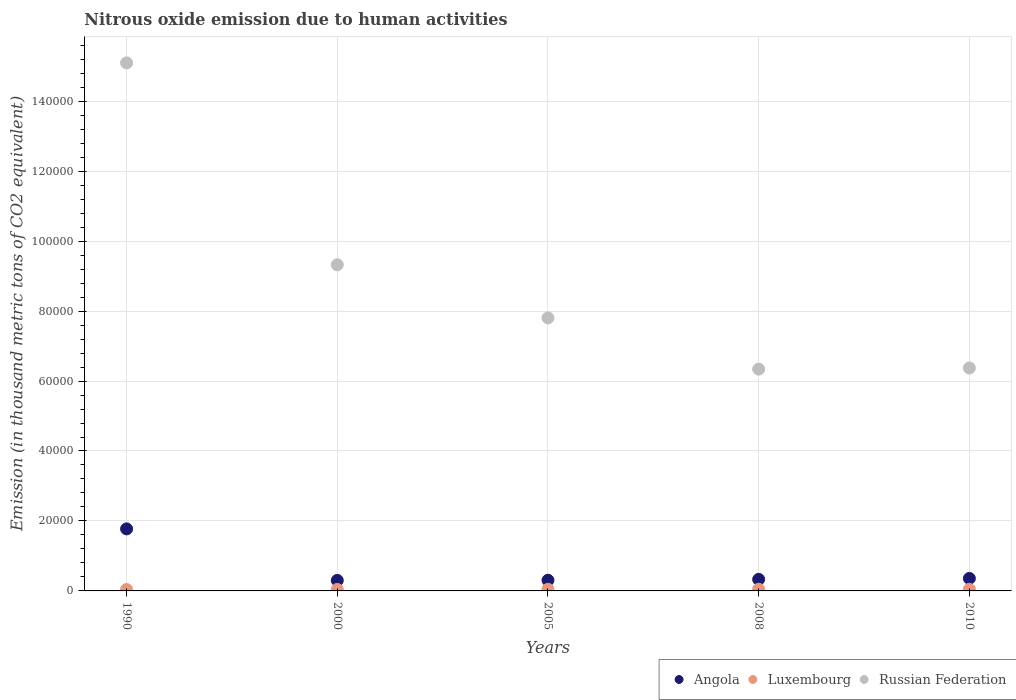How many different coloured dotlines are there?
Give a very brief answer. 3. What is the amount of nitrous oxide emitted in Luxembourg in 2005?
Keep it short and to the point. 467.2. Across all years, what is the maximum amount of nitrous oxide emitted in Angola?
Keep it short and to the point. 1.77e+04. Across all years, what is the minimum amount of nitrous oxide emitted in Russian Federation?
Ensure brevity in your answer.  6.34e+04. In which year was the amount of nitrous oxide emitted in Luxembourg maximum?
Offer a very short reply. 2008. What is the total amount of nitrous oxide emitted in Luxembourg in the graph?
Keep it short and to the point. 2253.6. What is the difference between the amount of nitrous oxide emitted in Angola in 1990 and that in 2010?
Offer a terse response. 1.42e+04. What is the difference between the amount of nitrous oxide emitted in Luxembourg in 2005 and the amount of nitrous oxide emitted in Angola in 2010?
Offer a terse response. -3102.6. What is the average amount of nitrous oxide emitted in Angola per year?
Your answer should be very brief. 6134.6. In the year 2005, what is the difference between the amount of nitrous oxide emitted in Luxembourg and amount of nitrous oxide emitted in Russian Federation?
Provide a succinct answer. -7.76e+04. In how many years, is the amount of nitrous oxide emitted in Russian Federation greater than 8000 thousand metric tons?
Your answer should be compact. 5. What is the ratio of the amount of nitrous oxide emitted in Russian Federation in 1990 to that in 2008?
Your answer should be very brief. 2.38. Is the amount of nitrous oxide emitted in Russian Federation in 2008 less than that in 2010?
Make the answer very short. Yes. What is the difference between the highest and the second highest amount of nitrous oxide emitted in Angola?
Your answer should be compact. 1.42e+04. What is the difference between the highest and the lowest amount of nitrous oxide emitted in Russian Federation?
Make the answer very short. 8.75e+04. Does the amount of nitrous oxide emitted in Russian Federation monotonically increase over the years?
Give a very brief answer. No. How many dotlines are there?
Offer a very short reply. 3. Does the graph contain grids?
Provide a short and direct response. Yes. What is the title of the graph?
Offer a very short reply. Nitrous oxide emission due to human activities. What is the label or title of the X-axis?
Keep it short and to the point. Years. What is the label or title of the Y-axis?
Your answer should be compact. Emission (in thousand metric tons of CO2 equivalent). What is the Emission (in thousand metric tons of CO2 equivalent) of Angola in 1990?
Make the answer very short. 1.77e+04. What is the Emission (in thousand metric tons of CO2 equivalent) of Luxembourg in 1990?
Your response must be concise. 402. What is the Emission (in thousand metric tons of CO2 equivalent) in Russian Federation in 1990?
Make the answer very short. 1.51e+05. What is the Emission (in thousand metric tons of CO2 equivalent) in Angola in 2000?
Provide a short and direct response. 3005.3. What is the Emission (in thousand metric tons of CO2 equivalent) in Luxembourg in 2000?
Offer a terse response. 425.6. What is the Emission (in thousand metric tons of CO2 equivalent) of Russian Federation in 2000?
Provide a short and direct response. 9.32e+04. What is the Emission (in thousand metric tons of CO2 equivalent) in Angola in 2005?
Provide a short and direct response. 3056.7. What is the Emission (in thousand metric tons of CO2 equivalent) in Luxembourg in 2005?
Your answer should be compact. 467.2. What is the Emission (in thousand metric tons of CO2 equivalent) in Russian Federation in 2005?
Your answer should be compact. 7.81e+04. What is the Emission (in thousand metric tons of CO2 equivalent) of Angola in 2008?
Offer a very short reply. 3307. What is the Emission (in thousand metric tons of CO2 equivalent) in Luxembourg in 2008?
Offer a terse response. 482.9. What is the Emission (in thousand metric tons of CO2 equivalent) in Russian Federation in 2008?
Your response must be concise. 6.34e+04. What is the Emission (in thousand metric tons of CO2 equivalent) of Angola in 2010?
Your answer should be compact. 3569.8. What is the Emission (in thousand metric tons of CO2 equivalent) in Luxembourg in 2010?
Your response must be concise. 475.9. What is the Emission (in thousand metric tons of CO2 equivalent) in Russian Federation in 2010?
Your response must be concise. 6.37e+04. Across all years, what is the maximum Emission (in thousand metric tons of CO2 equivalent) of Angola?
Give a very brief answer. 1.77e+04. Across all years, what is the maximum Emission (in thousand metric tons of CO2 equivalent) of Luxembourg?
Make the answer very short. 482.9. Across all years, what is the maximum Emission (in thousand metric tons of CO2 equivalent) of Russian Federation?
Provide a succinct answer. 1.51e+05. Across all years, what is the minimum Emission (in thousand metric tons of CO2 equivalent) in Angola?
Make the answer very short. 3005.3. Across all years, what is the minimum Emission (in thousand metric tons of CO2 equivalent) of Luxembourg?
Your answer should be compact. 402. Across all years, what is the minimum Emission (in thousand metric tons of CO2 equivalent) in Russian Federation?
Give a very brief answer. 6.34e+04. What is the total Emission (in thousand metric tons of CO2 equivalent) in Angola in the graph?
Ensure brevity in your answer.  3.07e+04. What is the total Emission (in thousand metric tons of CO2 equivalent) of Luxembourg in the graph?
Give a very brief answer. 2253.6. What is the total Emission (in thousand metric tons of CO2 equivalent) in Russian Federation in the graph?
Offer a very short reply. 4.49e+05. What is the difference between the Emission (in thousand metric tons of CO2 equivalent) in Angola in 1990 and that in 2000?
Provide a succinct answer. 1.47e+04. What is the difference between the Emission (in thousand metric tons of CO2 equivalent) of Luxembourg in 1990 and that in 2000?
Provide a succinct answer. -23.6. What is the difference between the Emission (in thousand metric tons of CO2 equivalent) in Russian Federation in 1990 and that in 2000?
Your answer should be compact. 5.77e+04. What is the difference between the Emission (in thousand metric tons of CO2 equivalent) in Angola in 1990 and that in 2005?
Give a very brief answer. 1.47e+04. What is the difference between the Emission (in thousand metric tons of CO2 equivalent) of Luxembourg in 1990 and that in 2005?
Your answer should be compact. -65.2. What is the difference between the Emission (in thousand metric tons of CO2 equivalent) of Russian Federation in 1990 and that in 2005?
Give a very brief answer. 7.29e+04. What is the difference between the Emission (in thousand metric tons of CO2 equivalent) in Angola in 1990 and that in 2008?
Ensure brevity in your answer.  1.44e+04. What is the difference between the Emission (in thousand metric tons of CO2 equivalent) of Luxembourg in 1990 and that in 2008?
Ensure brevity in your answer.  -80.9. What is the difference between the Emission (in thousand metric tons of CO2 equivalent) of Russian Federation in 1990 and that in 2008?
Provide a short and direct response. 8.75e+04. What is the difference between the Emission (in thousand metric tons of CO2 equivalent) in Angola in 1990 and that in 2010?
Provide a succinct answer. 1.42e+04. What is the difference between the Emission (in thousand metric tons of CO2 equivalent) in Luxembourg in 1990 and that in 2010?
Offer a terse response. -73.9. What is the difference between the Emission (in thousand metric tons of CO2 equivalent) in Russian Federation in 1990 and that in 2010?
Offer a very short reply. 8.72e+04. What is the difference between the Emission (in thousand metric tons of CO2 equivalent) of Angola in 2000 and that in 2005?
Provide a succinct answer. -51.4. What is the difference between the Emission (in thousand metric tons of CO2 equivalent) in Luxembourg in 2000 and that in 2005?
Make the answer very short. -41.6. What is the difference between the Emission (in thousand metric tons of CO2 equivalent) in Russian Federation in 2000 and that in 2005?
Keep it short and to the point. 1.52e+04. What is the difference between the Emission (in thousand metric tons of CO2 equivalent) of Angola in 2000 and that in 2008?
Provide a succinct answer. -301.7. What is the difference between the Emission (in thousand metric tons of CO2 equivalent) in Luxembourg in 2000 and that in 2008?
Your answer should be very brief. -57.3. What is the difference between the Emission (in thousand metric tons of CO2 equivalent) of Russian Federation in 2000 and that in 2008?
Offer a very short reply. 2.98e+04. What is the difference between the Emission (in thousand metric tons of CO2 equivalent) of Angola in 2000 and that in 2010?
Give a very brief answer. -564.5. What is the difference between the Emission (in thousand metric tons of CO2 equivalent) in Luxembourg in 2000 and that in 2010?
Give a very brief answer. -50.3. What is the difference between the Emission (in thousand metric tons of CO2 equivalent) of Russian Federation in 2000 and that in 2010?
Offer a terse response. 2.95e+04. What is the difference between the Emission (in thousand metric tons of CO2 equivalent) of Angola in 2005 and that in 2008?
Keep it short and to the point. -250.3. What is the difference between the Emission (in thousand metric tons of CO2 equivalent) in Luxembourg in 2005 and that in 2008?
Give a very brief answer. -15.7. What is the difference between the Emission (in thousand metric tons of CO2 equivalent) in Russian Federation in 2005 and that in 2008?
Your response must be concise. 1.46e+04. What is the difference between the Emission (in thousand metric tons of CO2 equivalent) of Angola in 2005 and that in 2010?
Provide a short and direct response. -513.1. What is the difference between the Emission (in thousand metric tons of CO2 equivalent) of Russian Federation in 2005 and that in 2010?
Provide a short and direct response. 1.43e+04. What is the difference between the Emission (in thousand metric tons of CO2 equivalent) in Angola in 2008 and that in 2010?
Ensure brevity in your answer.  -262.8. What is the difference between the Emission (in thousand metric tons of CO2 equivalent) of Luxembourg in 2008 and that in 2010?
Offer a very short reply. 7. What is the difference between the Emission (in thousand metric tons of CO2 equivalent) of Russian Federation in 2008 and that in 2010?
Ensure brevity in your answer.  -319.3. What is the difference between the Emission (in thousand metric tons of CO2 equivalent) in Angola in 1990 and the Emission (in thousand metric tons of CO2 equivalent) in Luxembourg in 2000?
Provide a short and direct response. 1.73e+04. What is the difference between the Emission (in thousand metric tons of CO2 equivalent) in Angola in 1990 and the Emission (in thousand metric tons of CO2 equivalent) in Russian Federation in 2000?
Your response must be concise. -7.55e+04. What is the difference between the Emission (in thousand metric tons of CO2 equivalent) in Luxembourg in 1990 and the Emission (in thousand metric tons of CO2 equivalent) in Russian Federation in 2000?
Provide a succinct answer. -9.28e+04. What is the difference between the Emission (in thousand metric tons of CO2 equivalent) in Angola in 1990 and the Emission (in thousand metric tons of CO2 equivalent) in Luxembourg in 2005?
Make the answer very short. 1.73e+04. What is the difference between the Emission (in thousand metric tons of CO2 equivalent) of Angola in 1990 and the Emission (in thousand metric tons of CO2 equivalent) of Russian Federation in 2005?
Make the answer very short. -6.03e+04. What is the difference between the Emission (in thousand metric tons of CO2 equivalent) in Luxembourg in 1990 and the Emission (in thousand metric tons of CO2 equivalent) in Russian Federation in 2005?
Make the answer very short. -7.76e+04. What is the difference between the Emission (in thousand metric tons of CO2 equivalent) in Angola in 1990 and the Emission (in thousand metric tons of CO2 equivalent) in Luxembourg in 2008?
Keep it short and to the point. 1.73e+04. What is the difference between the Emission (in thousand metric tons of CO2 equivalent) of Angola in 1990 and the Emission (in thousand metric tons of CO2 equivalent) of Russian Federation in 2008?
Provide a short and direct response. -4.57e+04. What is the difference between the Emission (in thousand metric tons of CO2 equivalent) of Luxembourg in 1990 and the Emission (in thousand metric tons of CO2 equivalent) of Russian Federation in 2008?
Your answer should be very brief. -6.30e+04. What is the difference between the Emission (in thousand metric tons of CO2 equivalent) in Angola in 1990 and the Emission (in thousand metric tons of CO2 equivalent) in Luxembourg in 2010?
Keep it short and to the point. 1.73e+04. What is the difference between the Emission (in thousand metric tons of CO2 equivalent) in Angola in 1990 and the Emission (in thousand metric tons of CO2 equivalent) in Russian Federation in 2010?
Offer a terse response. -4.60e+04. What is the difference between the Emission (in thousand metric tons of CO2 equivalent) in Luxembourg in 1990 and the Emission (in thousand metric tons of CO2 equivalent) in Russian Federation in 2010?
Offer a terse response. -6.33e+04. What is the difference between the Emission (in thousand metric tons of CO2 equivalent) in Angola in 2000 and the Emission (in thousand metric tons of CO2 equivalent) in Luxembourg in 2005?
Your answer should be compact. 2538.1. What is the difference between the Emission (in thousand metric tons of CO2 equivalent) in Angola in 2000 and the Emission (in thousand metric tons of CO2 equivalent) in Russian Federation in 2005?
Your answer should be very brief. -7.50e+04. What is the difference between the Emission (in thousand metric tons of CO2 equivalent) in Luxembourg in 2000 and the Emission (in thousand metric tons of CO2 equivalent) in Russian Federation in 2005?
Your response must be concise. -7.76e+04. What is the difference between the Emission (in thousand metric tons of CO2 equivalent) of Angola in 2000 and the Emission (in thousand metric tons of CO2 equivalent) of Luxembourg in 2008?
Provide a succinct answer. 2522.4. What is the difference between the Emission (in thousand metric tons of CO2 equivalent) of Angola in 2000 and the Emission (in thousand metric tons of CO2 equivalent) of Russian Federation in 2008?
Make the answer very short. -6.04e+04. What is the difference between the Emission (in thousand metric tons of CO2 equivalent) in Luxembourg in 2000 and the Emission (in thousand metric tons of CO2 equivalent) in Russian Federation in 2008?
Offer a very short reply. -6.30e+04. What is the difference between the Emission (in thousand metric tons of CO2 equivalent) of Angola in 2000 and the Emission (in thousand metric tons of CO2 equivalent) of Luxembourg in 2010?
Your response must be concise. 2529.4. What is the difference between the Emission (in thousand metric tons of CO2 equivalent) in Angola in 2000 and the Emission (in thousand metric tons of CO2 equivalent) in Russian Federation in 2010?
Keep it short and to the point. -6.07e+04. What is the difference between the Emission (in thousand metric tons of CO2 equivalent) in Luxembourg in 2000 and the Emission (in thousand metric tons of CO2 equivalent) in Russian Federation in 2010?
Ensure brevity in your answer.  -6.33e+04. What is the difference between the Emission (in thousand metric tons of CO2 equivalent) in Angola in 2005 and the Emission (in thousand metric tons of CO2 equivalent) in Luxembourg in 2008?
Your answer should be very brief. 2573.8. What is the difference between the Emission (in thousand metric tons of CO2 equivalent) in Angola in 2005 and the Emission (in thousand metric tons of CO2 equivalent) in Russian Federation in 2008?
Offer a terse response. -6.04e+04. What is the difference between the Emission (in thousand metric tons of CO2 equivalent) of Luxembourg in 2005 and the Emission (in thousand metric tons of CO2 equivalent) of Russian Federation in 2008?
Make the answer very short. -6.29e+04. What is the difference between the Emission (in thousand metric tons of CO2 equivalent) in Angola in 2005 and the Emission (in thousand metric tons of CO2 equivalent) in Luxembourg in 2010?
Provide a short and direct response. 2580.8. What is the difference between the Emission (in thousand metric tons of CO2 equivalent) in Angola in 2005 and the Emission (in thousand metric tons of CO2 equivalent) in Russian Federation in 2010?
Make the answer very short. -6.07e+04. What is the difference between the Emission (in thousand metric tons of CO2 equivalent) of Luxembourg in 2005 and the Emission (in thousand metric tons of CO2 equivalent) of Russian Federation in 2010?
Offer a very short reply. -6.33e+04. What is the difference between the Emission (in thousand metric tons of CO2 equivalent) in Angola in 2008 and the Emission (in thousand metric tons of CO2 equivalent) in Luxembourg in 2010?
Make the answer very short. 2831.1. What is the difference between the Emission (in thousand metric tons of CO2 equivalent) of Angola in 2008 and the Emission (in thousand metric tons of CO2 equivalent) of Russian Federation in 2010?
Your answer should be compact. -6.04e+04. What is the difference between the Emission (in thousand metric tons of CO2 equivalent) in Luxembourg in 2008 and the Emission (in thousand metric tons of CO2 equivalent) in Russian Federation in 2010?
Provide a succinct answer. -6.32e+04. What is the average Emission (in thousand metric tons of CO2 equivalent) of Angola per year?
Your response must be concise. 6134.6. What is the average Emission (in thousand metric tons of CO2 equivalent) of Luxembourg per year?
Give a very brief answer. 450.72. What is the average Emission (in thousand metric tons of CO2 equivalent) of Russian Federation per year?
Your answer should be compact. 8.99e+04. In the year 1990, what is the difference between the Emission (in thousand metric tons of CO2 equivalent) in Angola and Emission (in thousand metric tons of CO2 equivalent) in Luxembourg?
Your answer should be very brief. 1.73e+04. In the year 1990, what is the difference between the Emission (in thousand metric tons of CO2 equivalent) of Angola and Emission (in thousand metric tons of CO2 equivalent) of Russian Federation?
Offer a very short reply. -1.33e+05. In the year 1990, what is the difference between the Emission (in thousand metric tons of CO2 equivalent) of Luxembourg and Emission (in thousand metric tons of CO2 equivalent) of Russian Federation?
Your answer should be very brief. -1.51e+05. In the year 2000, what is the difference between the Emission (in thousand metric tons of CO2 equivalent) of Angola and Emission (in thousand metric tons of CO2 equivalent) of Luxembourg?
Your answer should be compact. 2579.7. In the year 2000, what is the difference between the Emission (in thousand metric tons of CO2 equivalent) of Angola and Emission (in thousand metric tons of CO2 equivalent) of Russian Federation?
Keep it short and to the point. -9.02e+04. In the year 2000, what is the difference between the Emission (in thousand metric tons of CO2 equivalent) in Luxembourg and Emission (in thousand metric tons of CO2 equivalent) in Russian Federation?
Make the answer very short. -9.28e+04. In the year 2005, what is the difference between the Emission (in thousand metric tons of CO2 equivalent) of Angola and Emission (in thousand metric tons of CO2 equivalent) of Luxembourg?
Give a very brief answer. 2589.5. In the year 2005, what is the difference between the Emission (in thousand metric tons of CO2 equivalent) in Angola and Emission (in thousand metric tons of CO2 equivalent) in Russian Federation?
Give a very brief answer. -7.50e+04. In the year 2005, what is the difference between the Emission (in thousand metric tons of CO2 equivalent) in Luxembourg and Emission (in thousand metric tons of CO2 equivalent) in Russian Federation?
Provide a short and direct response. -7.76e+04. In the year 2008, what is the difference between the Emission (in thousand metric tons of CO2 equivalent) in Angola and Emission (in thousand metric tons of CO2 equivalent) in Luxembourg?
Your answer should be very brief. 2824.1. In the year 2008, what is the difference between the Emission (in thousand metric tons of CO2 equivalent) in Angola and Emission (in thousand metric tons of CO2 equivalent) in Russian Federation?
Your response must be concise. -6.01e+04. In the year 2008, what is the difference between the Emission (in thousand metric tons of CO2 equivalent) in Luxembourg and Emission (in thousand metric tons of CO2 equivalent) in Russian Federation?
Make the answer very short. -6.29e+04. In the year 2010, what is the difference between the Emission (in thousand metric tons of CO2 equivalent) of Angola and Emission (in thousand metric tons of CO2 equivalent) of Luxembourg?
Your answer should be compact. 3093.9. In the year 2010, what is the difference between the Emission (in thousand metric tons of CO2 equivalent) in Angola and Emission (in thousand metric tons of CO2 equivalent) in Russian Federation?
Provide a short and direct response. -6.02e+04. In the year 2010, what is the difference between the Emission (in thousand metric tons of CO2 equivalent) of Luxembourg and Emission (in thousand metric tons of CO2 equivalent) of Russian Federation?
Your response must be concise. -6.33e+04. What is the ratio of the Emission (in thousand metric tons of CO2 equivalent) in Angola in 1990 to that in 2000?
Keep it short and to the point. 5.9. What is the ratio of the Emission (in thousand metric tons of CO2 equivalent) of Luxembourg in 1990 to that in 2000?
Ensure brevity in your answer.  0.94. What is the ratio of the Emission (in thousand metric tons of CO2 equivalent) in Russian Federation in 1990 to that in 2000?
Provide a short and direct response. 1.62. What is the ratio of the Emission (in thousand metric tons of CO2 equivalent) in Angola in 1990 to that in 2005?
Ensure brevity in your answer.  5.8. What is the ratio of the Emission (in thousand metric tons of CO2 equivalent) in Luxembourg in 1990 to that in 2005?
Keep it short and to the point. 0.86. What is the ratio of the Emission (in thousand metric tons of CO2 equivalent) in Russian Federation in 1990 to that in 2005?
Make the answer very short. 1.93. What is the ratio of the Emission (in thousand metric tons of CO2 equivalent) in Angola in 1990 to that in 2008?
Keep it short and to the point. 5.36. What is the ratio of the Emission (in thousand metric tons of CO2 equivalent) in Luxembourg in 1990 to that in 2008?
Ensure brevity in your answer.  0.83. What is the ratio of the Emission (in thousand metric tons of CO2 equivalent) in Russian Federation in 1990 to that in 2008?
Keep it short and to the point. 2.38. What is the ratio of the Emission (in thousand metric tons of CO2 equivalent) of Angola in 1990 to that in 2010?
Give a very brief answer. 4.97. What is the ratio of the Emission (in thousand metric tons of CO2 equivalent) in Luxembourg in 1990 to that in 2010?
Keep it short and to the point. 0.84. What is the ratio of the Emission (in thousand metric tons of CO2 equivalent) in Russian Federation in 1990 to that in 2010?
Provide a succinct answer. 2.37. What is the ratio of the Emission (in thousand metric tons of CO2 equivalent) of Angola in 2000 to that in 2005?
Give a very brief answer. 0.98. What is the ratio of the Emission (in thousand metric tons of CO2 equivalent) of Luxembourg in 2000 to that in 2005?
Offer a terse response. 0.91. What is the ratio of the Emission (in thousand metric tons of CO2 equivalent) in Russian Federation in 2000 to that in 2005?
Offer a very short reply. 1.19. What is the ratio of the Emission (in thousand metric tons of CO2 equivalent) in Angola in 2000 to that in 2008?
Your answer should be compact. 0.91. What is the ratio of the Emission (in thousand metric tons of CO2 equivalent) of Luxembourg in 2000 to that in 2008?
Ensure brevity in your answer.  0.88. What is the ratio of the Emission (in thousand metric tons of CO2 equivalent) of Russian Federation in 2000 to that in 2008?
Keep it short and to the point. 1.47. What is the ratio of the Emission (in thousand metric tons of CO2 equivalent) in Angola in 2000 to that in 2010?
Your answer should be very brief. 0.84. What is the ratio of the Emission (in thousand metric tons of CO2 equivalent) of Luxembourg in 2000 to that in 2010?
Offer a terse response. 0.89. What is the ratio of the Emission (in thousand metric tons of CO2 equivalent) of Russian Federation in 2000 to that in 2010?
Make the answer very short. 1.46. What is the ratio of the Emission (in thousand metric tons of CO2 equivalent) of Angola in 2005 to that in 2008?
Your answer should be compact. 0.92. What is the ratio of the Emission (in thousand metric tons of CO2 equivalent) in Luxembourg in 2005 to that in 2008?
Offer a very short reply. 0.97. What is the ratio of the Emission (in thousand metric tons of CO2 equivalent) of Russian Federation in 2005 to that in 2008?
Offer a very short reply. 1.23. What is the ratio of the Emission (in thousand metric tons of CO2 equivalent) of Angola in 2005 to that in 2010?
Provide a short and direct response. 0.86. What is the ratio of the Emission (in thousand metric tons of CO2 equivalent) in Luxembourg in 2005 to that in 2010?
Your response must be concise. 0.98. What is the ratio of the Emission (in thousand metric tons of CO2 equivalent) in Russian Federation in 2005 to that in 2010?
Provide a short and direct response. 1.22. What is the ratio of the Emission (in thousand metric tons of CO2 equivalent) of Angola in 2008 to that in 2010?
Offer a terse response. 0.93. What is the ratio of the Emission (in thousand metric tons of CO2 equivalent) in Luxembourg in 2008 to that in 2010?
Ensure brevity in your answer.  1.01. What is the ratio of the Emission (in thousand metric tons of CO2 equivalent) of Russian Federation in 2008 to that in 2010?
Ensure brevity in your answer.  0.99. What is the difference between the highest and the second highest Emission (in thousand metric tons of CO2 equivalent) in Angola?
Make the answer very short. 1.42e+04. What is the difference between the highest and the second highest Emission (in thousand metric tons of CO2 equivalent) of Russian Federation?
Offer a very short reply. 5.77e+04. What is the difference between the highest and the lowest Emission (in thousand metric tons of CO2 equivalent) in Angola?
Offer a terse response. 1.47e+04. What is the difference between the highest and the lowest Emission (in thousand metric tons of CO2 equivalent) of Luxembourg?
Your answer should be compact. 80.9. What is the difference between the highest and the lowest Emission (in thousand metric tons of CO2 equivalent) of Russian Federation?
Offer a very short reply. 8.75e+04. 